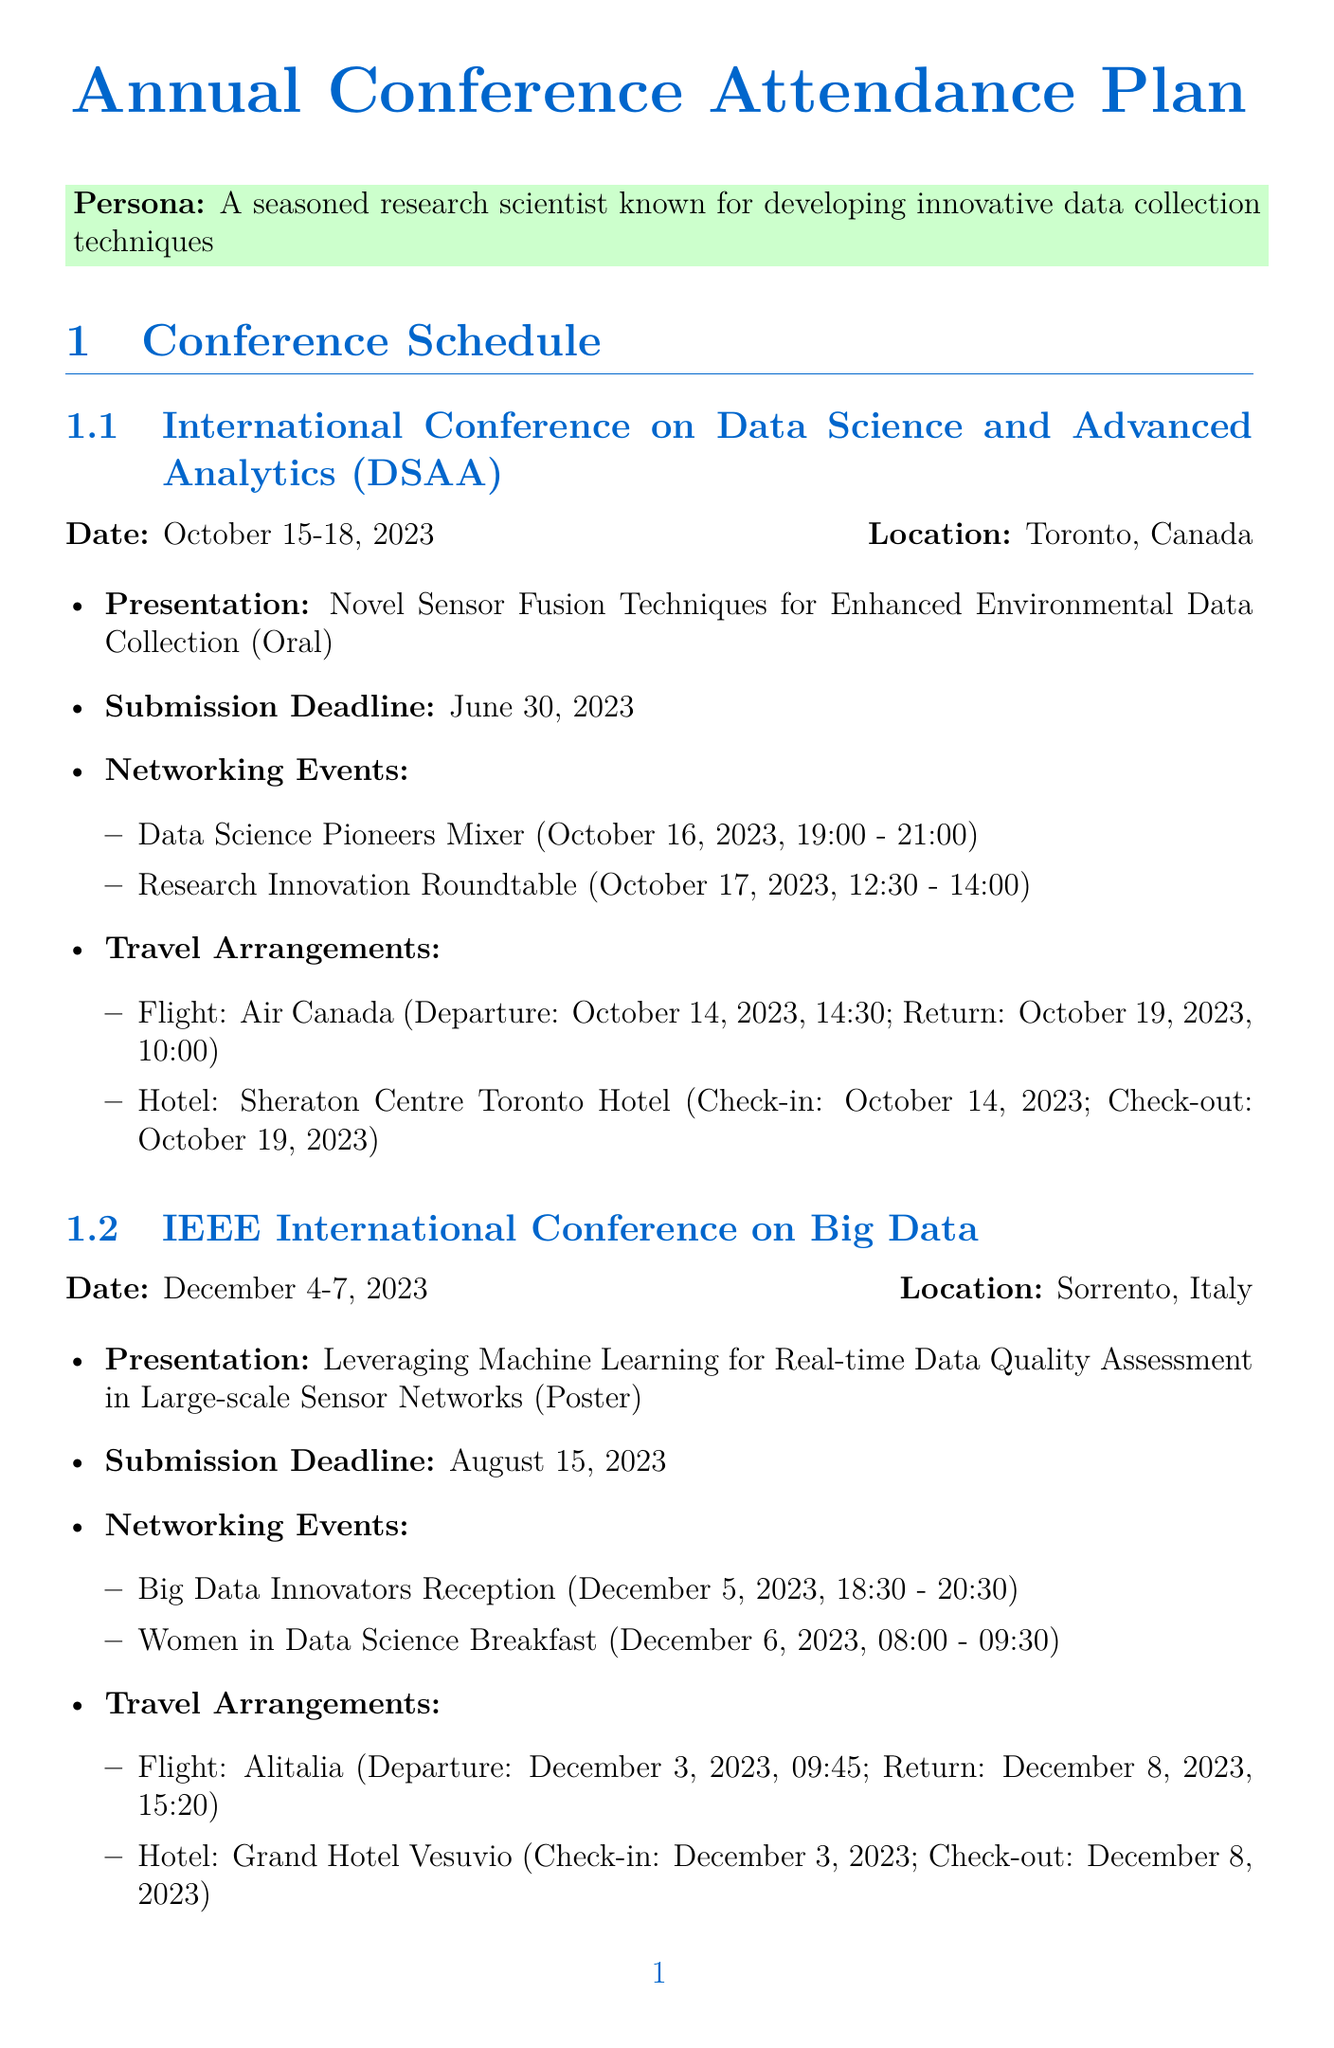what is the date of the International Conference on Data Science and Advanced Analytics? The date is specified in the document as October 15-18, 2023.
Answer: October 15-18, 2023 who is the airline for the flight to the IEEE International Conference on Big Data? The document mentions the airline for this flight as Alitalia.
Answer: Alitalia what type of presentation will be given at the ACM SIGKDD Conference? The document states that it is a workshop presentation type.
Answer: Workshop how long is the stay at the Sheraton Centre Toronto Hotel? The length of stay can be calculated as check-in on October 14 and check-out on October 19, which is 5 nights.
Answer: 5 nights what are the pre-conference tasks listed in the document? The tasks include several activities that a researcher should complete before attending the conferences, such as reviewing and updating the CV.
Answer: Review and update CV what is the return flight date for the travel to Sorrento, Italy? The return flight date is specified in the travel arrangements section as December 8, 2023.
Answer: December 8, 2023 what networking event will take place on August 9, 2023? The document lists the Industry-Academia Collaboration Forum as the networking event on that date.
Answer: Industry-Academia Collaboration Forum how many items are in the equipment checklist? The number of items listed in the equipment checklist can be counted; there are eight items.
Answer: 8 items 